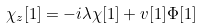<formula> <loc_0><loc_0><loc_500><loc_500>\chi _ { z } [ 1 ] = - i \lambda \chi [ 1 ] + v [ 1 ] \Phi [ 1 ]</formula> 